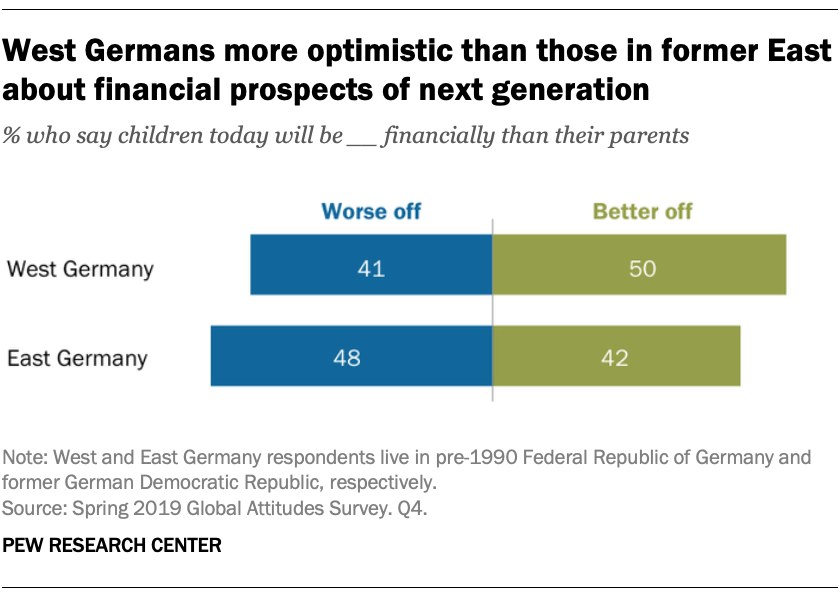Draw attention to some important aspects in this diagram. In East Germany, the value of the better off is the highest among all the categories. A significant proportion of people in West Germany, around 41%, believe that children today will be financially worse off than their parents. 